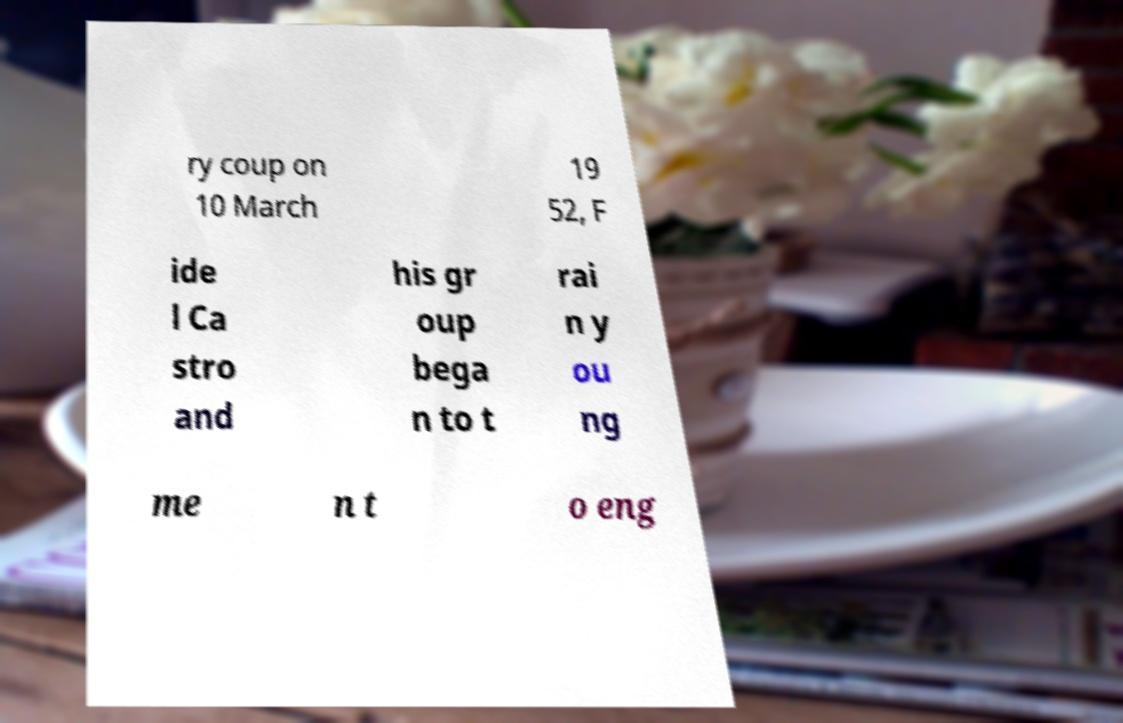What messages or text are displayed in this image? I need them in a readable, typed format. ry coup on 10 March 19 52, F ide l Ca stro and his gr oup bega n to t rai n y ou ng me n t o eng 